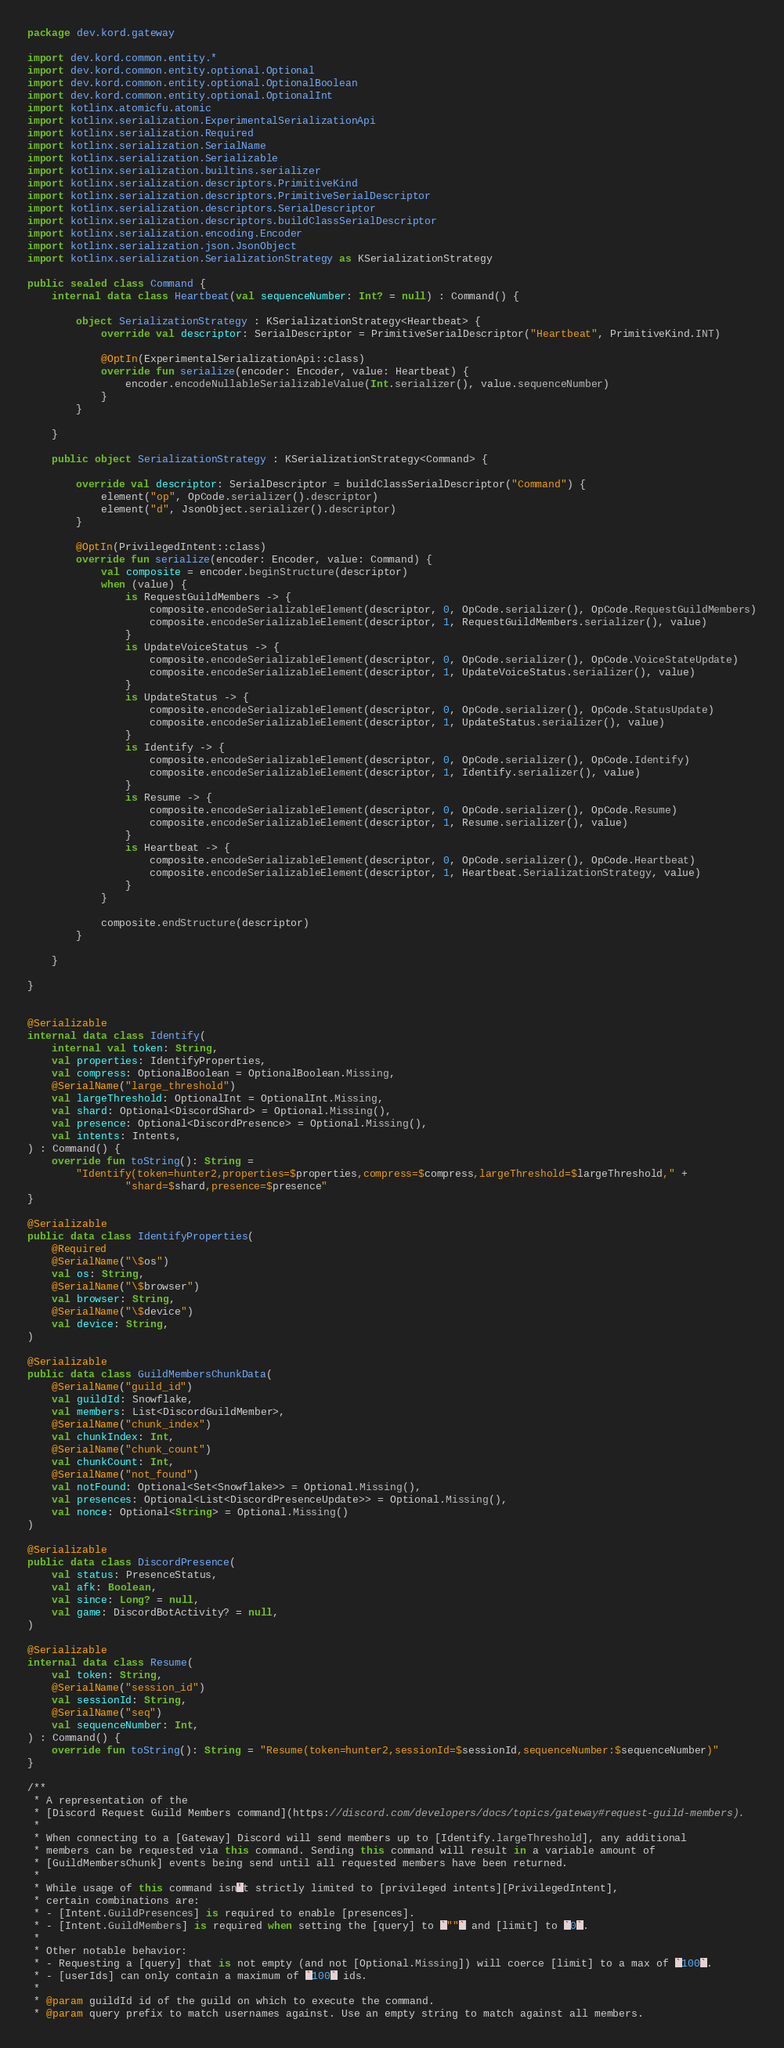<code> <loc_0><loc_0><loc_500><loc_500><_Kotlin_>package dev.kord.gateway

import dev.kord.common.entity.*
import dev.kord.common.entity.optional.Optional
import dev.kord.common.entity.optional.OptionalBoolean
import dev.kord.common.entity.optional.OptionalInt
import kotlinx.atomicfu.atomic
import kotlinx.serialization.ExperimentalSerializationApi
import kotlinx.serialization.Required
import kotlinx.serialization.SerialName
import kotlinx.serialization.Serializable
import kotlinx.serialization.builtins.serializer
import kotlinx.serialization.descriptors.PrimitiveKind
import kotlinx.serialization.descriptors.PrimitiveSerialDescriptor
import kotlinx.serialization.descriptors.SerialDescriptor
import kotlinx.serialization.descriptors.buildClassSerialDescriptor
import kotlinx.serialization.encoding.Encoder
import kotlinx.serialization.json.JsonObject
import kotlinx.serialization.SerializationStrategy as KSerializationStrategy

public sealed class Command {
    internal data class Heartbeat(val sequenceNumber: Int? = null) : Command() {

        object SerializationStrategy : KSerializationStrategy<Heartbeat> {
            override val descriptor: SerialDescriptor = PrimitiveSerialDescriptor("Heartbeat", PrimitiveKind.INT)

            @OptIn(ExperimentalSerializationApi::class)
            override fun serialize(encoder: Encoder, value: Heartbeat) {
                encoder.encodeNullableSerializableValue(Int.serializer(), value.sequenceNumber)
            }
        }

    }

    public object SerializationStrategy : KSerializationStrategy<Command> {

        override val descriptor: SerialDescriptor = buildClassSerialDescriptor("Command") {
            element("op", OpCode.serializer().descriptor)
            element("d", JsonObject.serializer().descriptor)
        }

        @OptIn(PrivilegedIntent::class)
        override fun serialize(encoder: Encoder, value: Command) {
            val composite = encoder.beginStructure(descriptor)
            when (value) {
                is RequestGuildMembers -> {
                    composite.encodeSerializableElement(descriptor, 0, OpCode.serializer(), OpCode.RequestGuildMembers)
                    composite.encodeSerializableElement(descriptor, 1, RequestGuildMembers.serializer(), value)
                }
                is UpdateVoiceStatus -> {
                    composite.encodeSerializableElement(descriptor, 0, OpCode.serializer(), OpCode.VoiceStateUpdate)
                    composite.encodeSerializableElement(descriptor, 1, UpdateVoiceStatus.serializer(), value)
                }
                is UpdateStatus -> {
                    composite.encodeSerializableElement(descriptor, 0, OpCode.serializer(), OpCode.StatusUpdate)
                    composite.encodeSerializableElement(descriptor, 1, UpdateStatus.serializer(), value)
                }
                is Identify -> {
                    composite.encodeSerializableElement(descriptor, 0, OpCode.serializer(), OpCode.Identify)
                    composite.encodeSerializableElement(descriptor, 1, Identify.serializer(), value)
                }
                is Resume -> {
                    composite.encodeSerializableElement(descriptor, 0, OpCode.serializer(), OpCode.Resume)
                    composite.encodeSerializableElement(descriptor, 1, Resume.serializer(), value)
                }
                is Heartbeat -> {
                    composite.encodeSerializableElement(descriptor, 0, OpCode.serializer(), OpCode.Heartbeat)
                    composite.encodeSerializableElement(descriptor, 1, Heartbeat.SerializationStrategy, value)
                }
            }

            composite.endStructure(descriptor)
        }

    }

}


@Serializable
internal data class Identify(
    internal val token: String,
    val properties: IdentifyProperties,
    val compress: OptionalBoolean = OptionalBoolean.Missing,
    @SerialName("large_threshold")
    val largeThreshold: OptionalInt = OptionalInt.Missing,
    val shard: Optional<DiscordShard> = Optional.Missing(),
    val presence: Optional<DiscordPresence> = Optional.Missing(),
    val intents: Intents,
) : Command() {
    override fun toString(): String =
        "Identify(token=hunter2,properties=$properties,compress=$compress,largeThreshold=$largeThreshold," +
                "shard=$shard,presence=$presence"
}

@Serializable
public data class IdentifyProperties(
    @Required
    @SerialName("\$os")
    val os: String,
    @SerialName("\$browser")
    val browser: String,
    @SerialName("\$device")
    val device: String,
)

@Serializable
public data class GuildMembersChunkData(
    @SerialName("guild_id")
    val guildId: Snowflake,
    val members: List<DiscordGuildMember>,
    @SerialName("chunk_index")
    val chunkIndex: Int,
    @SerialName("chunk_count")
    val chunkCount: Int,
    @SerialName("not_found")
    val notFound: Optional<Set<Snowflake>> = Optional.Missing(),
    val presences: Optional<List<DiscordPresenceUpdate>> = Optional.Missing(),
    val nonce: Optional<String> = Optional.Missing()
)

@Serializable
public data class DiscordPresence(
    val status: PresenceStatus,
    val afk: Boolean,
    val since: Long? = null,
    val game: DiscordBotActivity? = null,
)

@Serializable
internal data class Resume(
    val token: String,
    @SerialName("session_id")
    val sessionId: String,
    @SerialName("seq")
    val sequenceNumber: Int,
) : Command() {
    override fun toString(): String = "Resume(token=hunter2,sessionId=$sessionId,sequenceNumber:$sequenceNumber)"
}

/**
 * A representation of the
 * [Discord Request Guild Members command](https://discord.com/developers/docs/topics/gateway#request-guild-members).
 *
 * When connecting to a [Gateway] Discord will send members up to [Identify.largeThreshold], any additional
 * members can be requested via this command. Sending this command will result in a variable amount of
 * [GuildMembersChunk] events being send until all requested members have been returned.
 *
 * While usage of this command isn't strictly limited to [privileged intents][PrivilegedIntent],
 * certain combinations are:
 * - [Intent.GuildPresences] is required to enable [presences].
 * - [Intent.GuildMembers] is required when setting the [query] to `""` and [limit] to `0`.
 *
 * Other notable behavior:
 * - Requesting a [query] that is not empty (and not [Optional.Missing]) will coerce [limit] to a max of `100`.
 * - [userIds] can only contain a maximum of `100` ids.
 *
 * @param guildId id of the guild on which to execute the command.
 * @param query prefix to match usernames against. Use an empty string to match against all members.</code> 